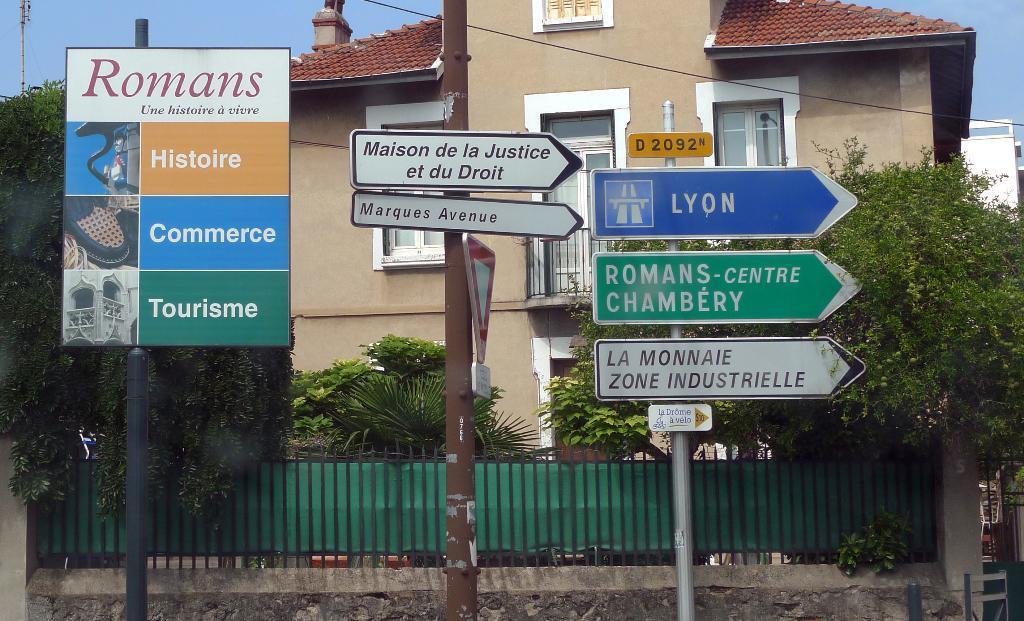Describe this image in one or two sentences. In this image I can see three poles in the front and on it I can see number of boards. I can also see something is written on these boards. In the background I can see few trees, few buildings, a wire and the sky. 